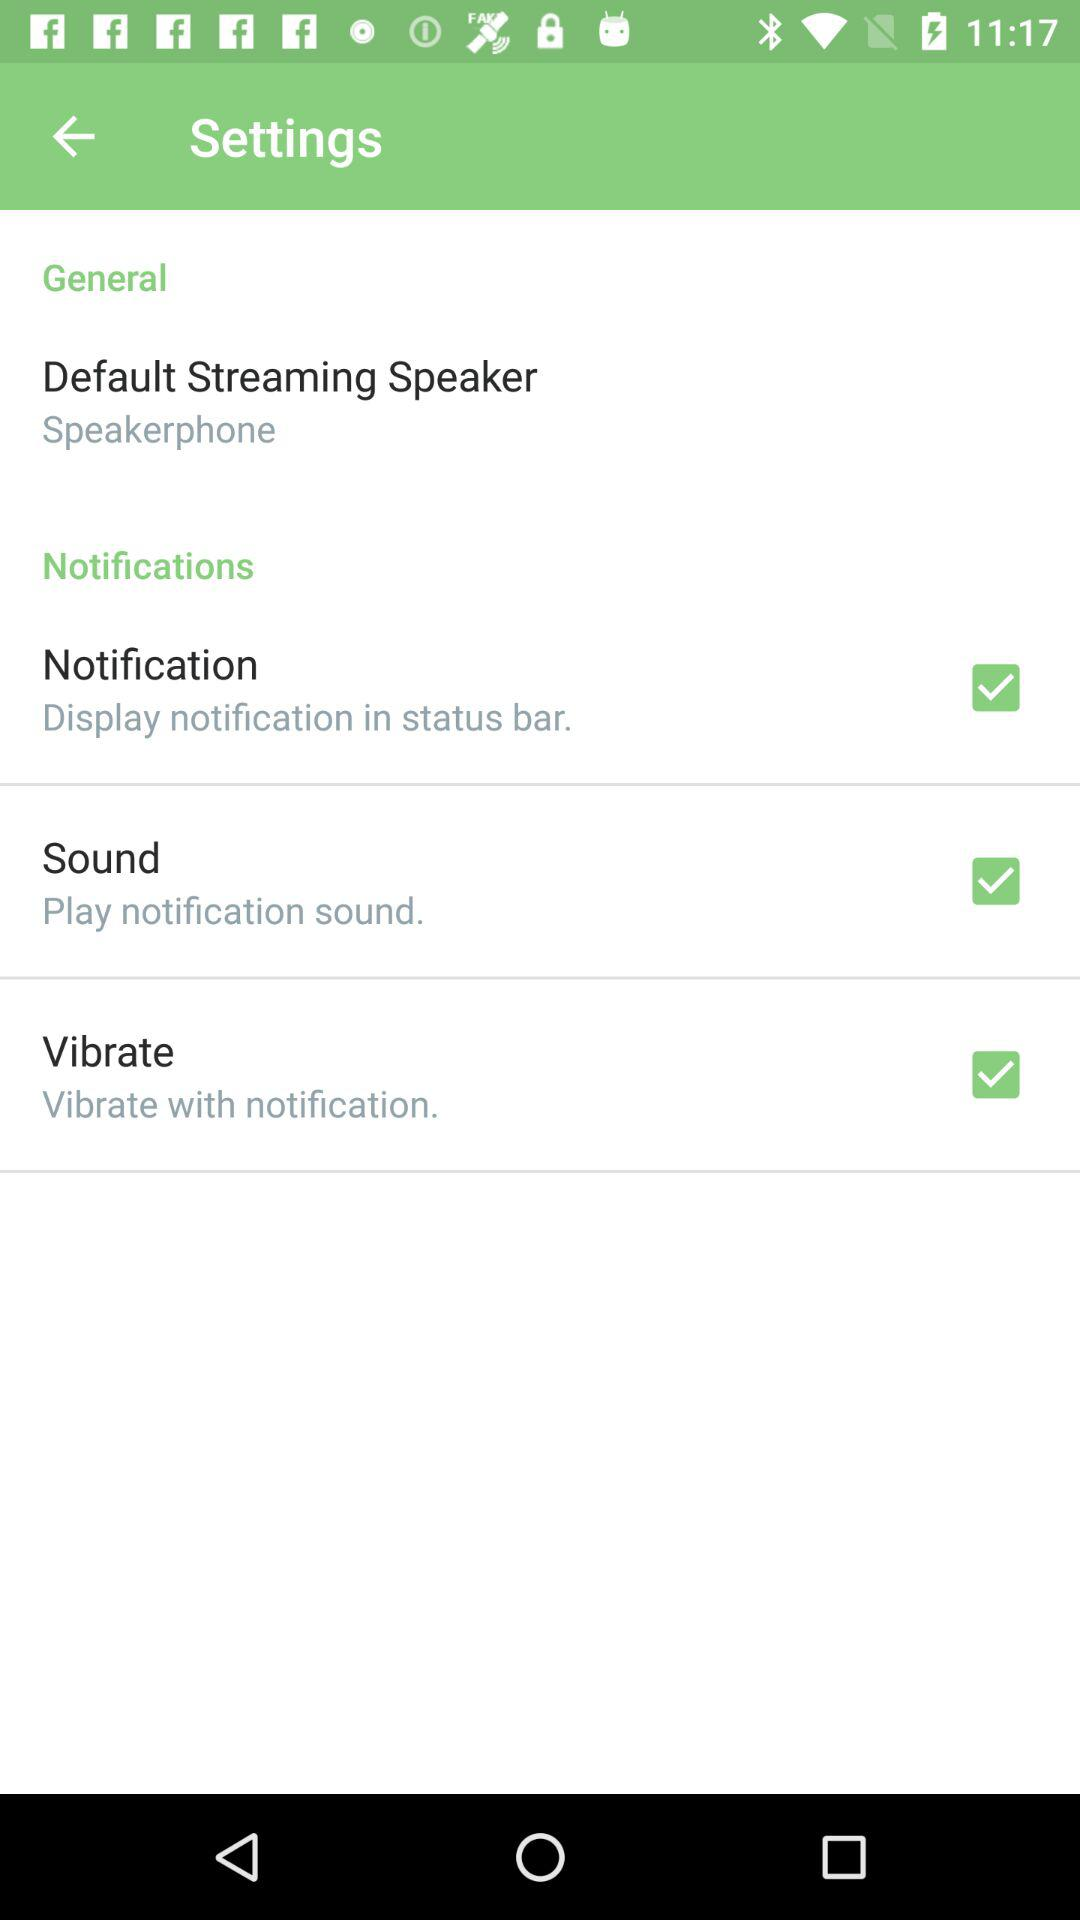What's the general setting for the default streaming speaker? The general setting for the default streaming speaker is "Speakerphone". 